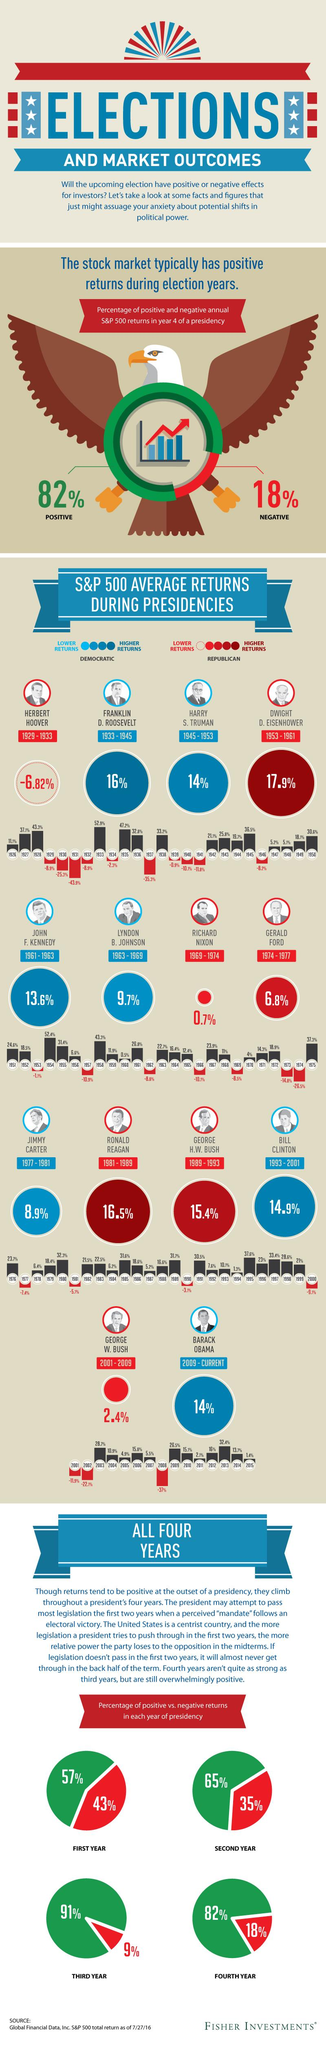Identify some key points in this picture. The highest average returns among Democratic presidencies was 16%. During the presidency of Richard Nixon, the average returns of the S&P 500 were 0.7%. The highest average returns percentage was achieved during the presidency of Dwight D. Eisenhower. During the presidency of George H.W. Bush, the average returns of the S&P 500 were 15.4%. During the presidency of Herbert Hoover, a negative average returns percentage was shown. 